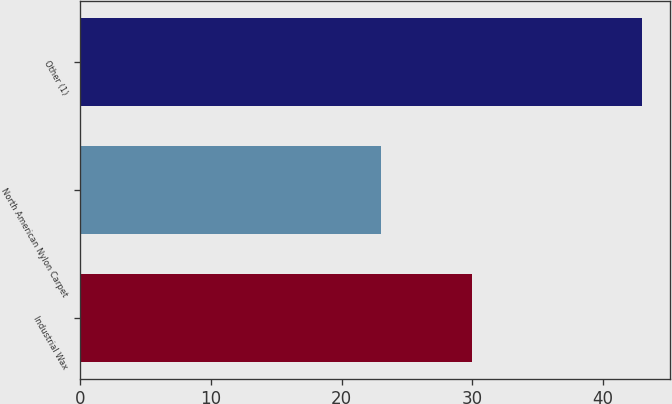Convert chart to OTSL. <chart><loc_0><loc_0><loc_500><loc_500><bar_chart><fcel>Industrial Wax<fcel>North American Nylon Carpet<fcel>Other (1)<nl><fcel>30<fcel>23<fcel>43<nl></chart> 